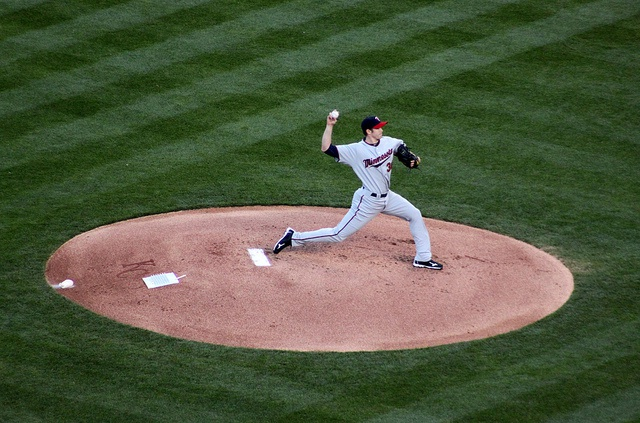Describe the objects in this image and their specific colors. I can see people in darkgreen, lavender, darkgray, and black tones, baseball glove in darkgreen, black, and gray tones, and sports ball in darkgreen, white, pink, and darkgray tones in this image. 